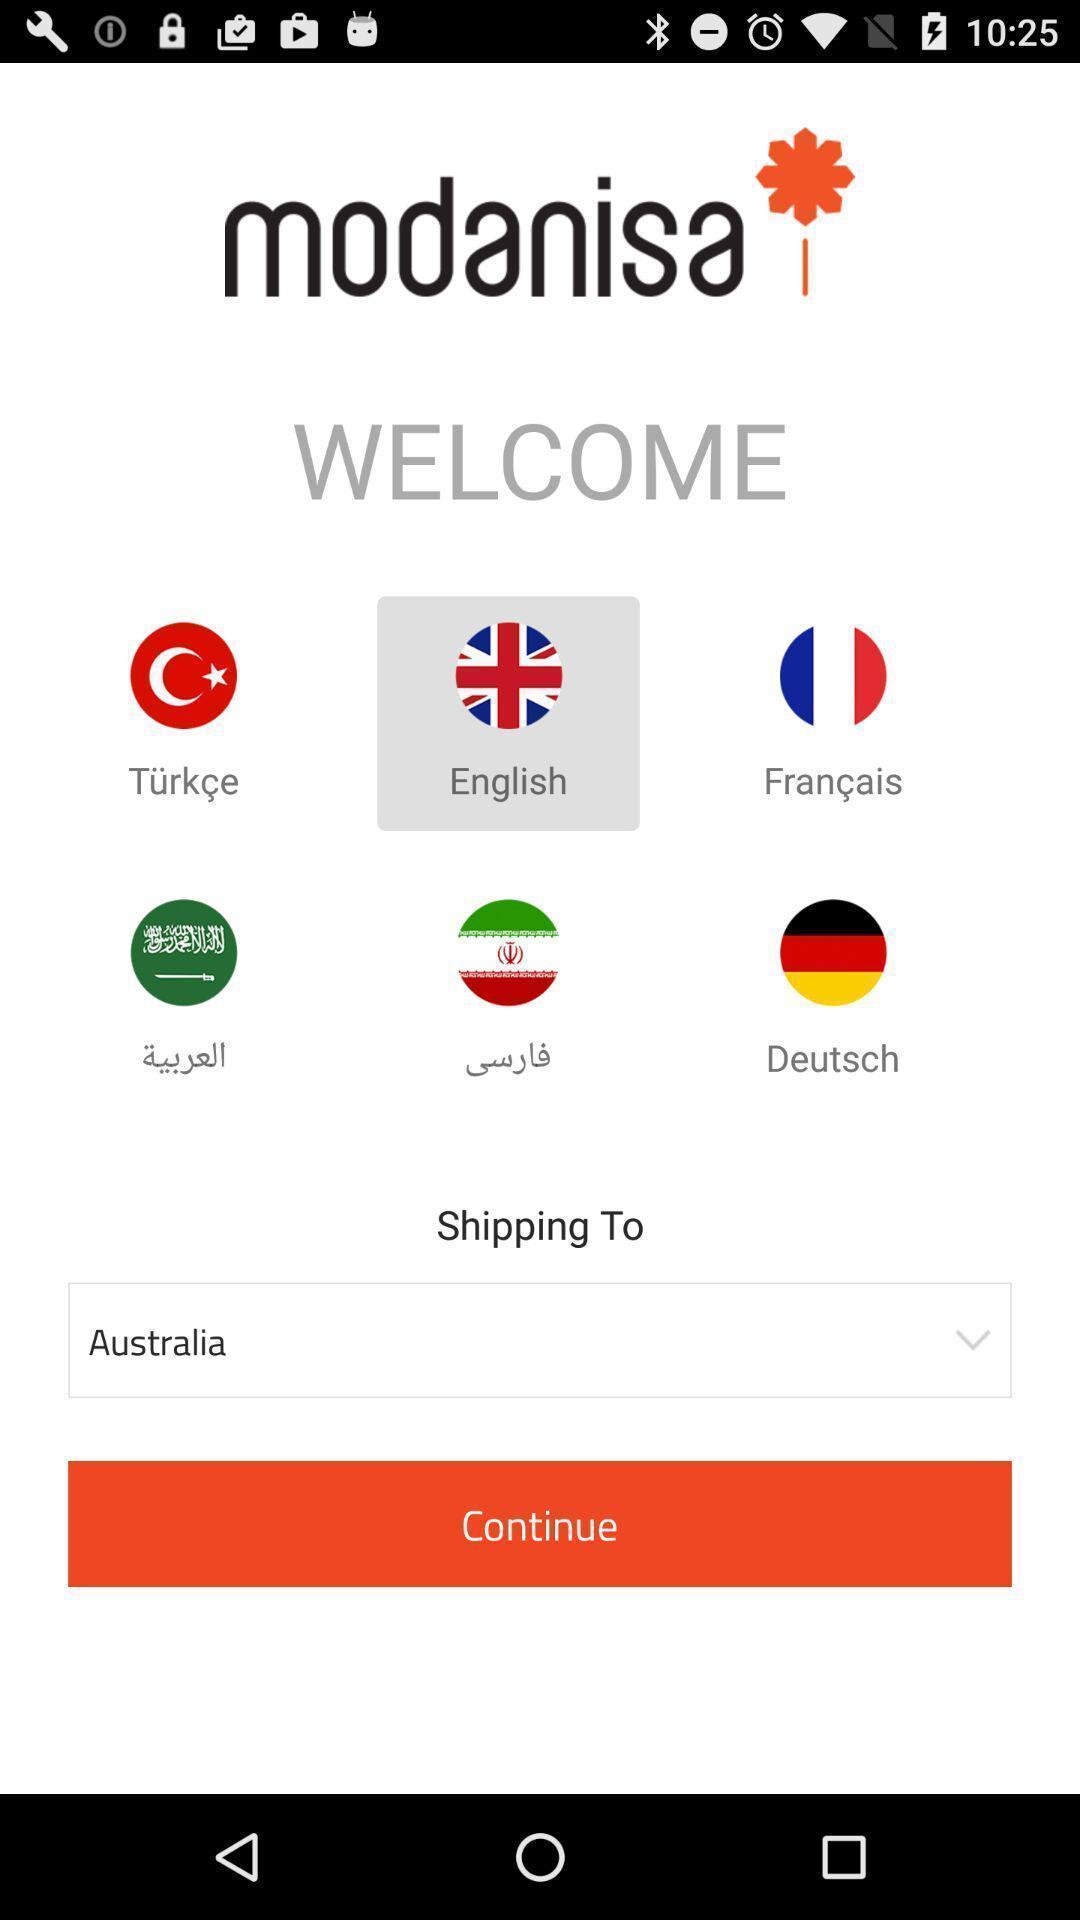What is the overall content of this screenshot? Welcome page showing different country logos. 